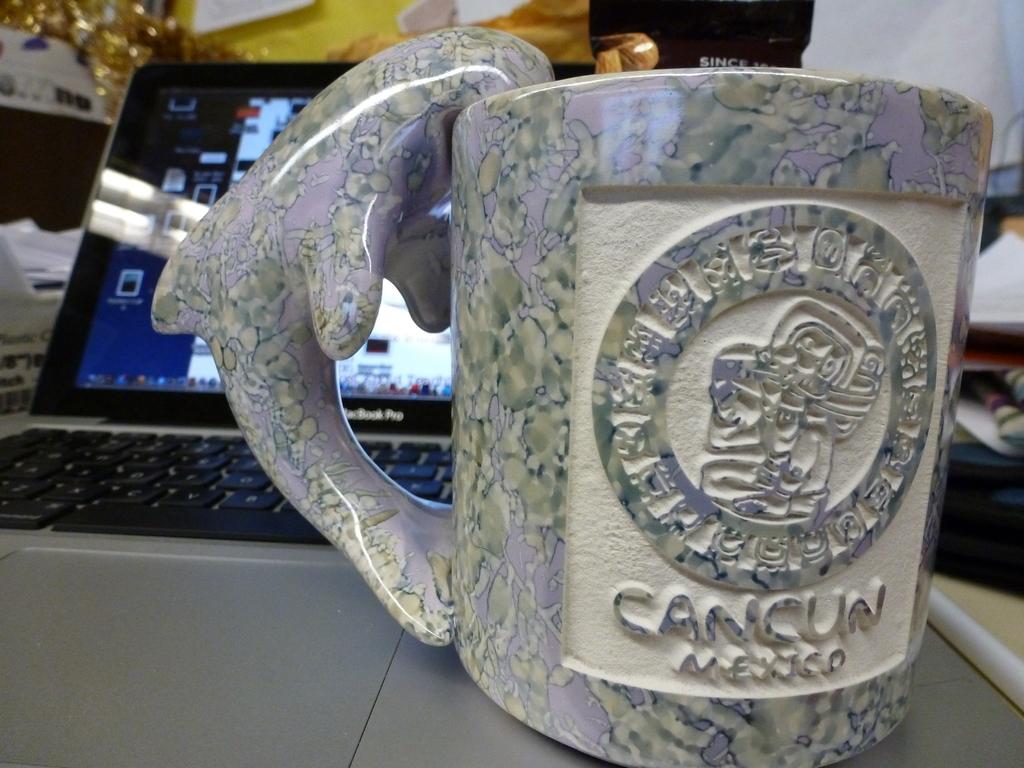What city is on the mug?
Offer a very short reply. Cancun. Is that the word mexico under the word cancun?
Your answer should be compact. Yes. 